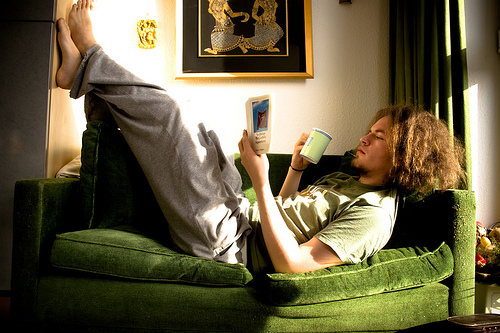<image>
Is there a mug above the sofa? Yes. The mug is positioned above the sofa in the vertical space, higher up in the scene. Where is the man in relation to the wall? Is it on the wall? No. The man is not positioned on the wall. They may be near each other, but the man is not supported by or resting on top of the wall. 